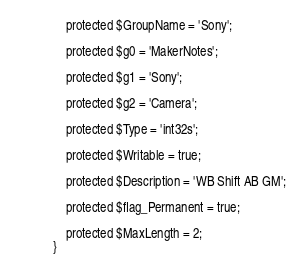<code> <loc_0><loc_0><loc_500><loc_500><_PHP_>    protected $GroupName = 'Sony';

    protected $g0 = 'MakerNotes';

    protected $g1 = 'Sony';

    protected $g2 = 'Camera';

    protected $Type = 'int32s';

    protected $Writable = true;

    protected $Description = 'WB Shift AB GM';

    protected $flag_Permanent = true;

    protected $MaxLength = 2;
}
</code> 